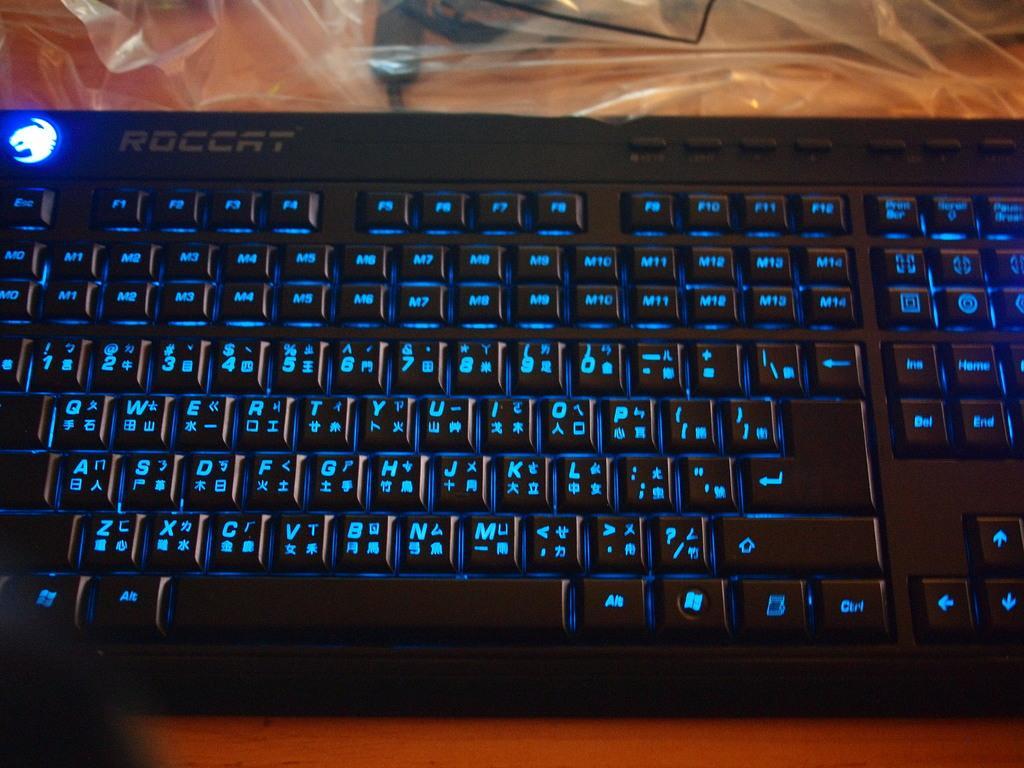How would you summarize this image in a sentence or two? In this image we can see a keyboard and a cover placed on the table. 